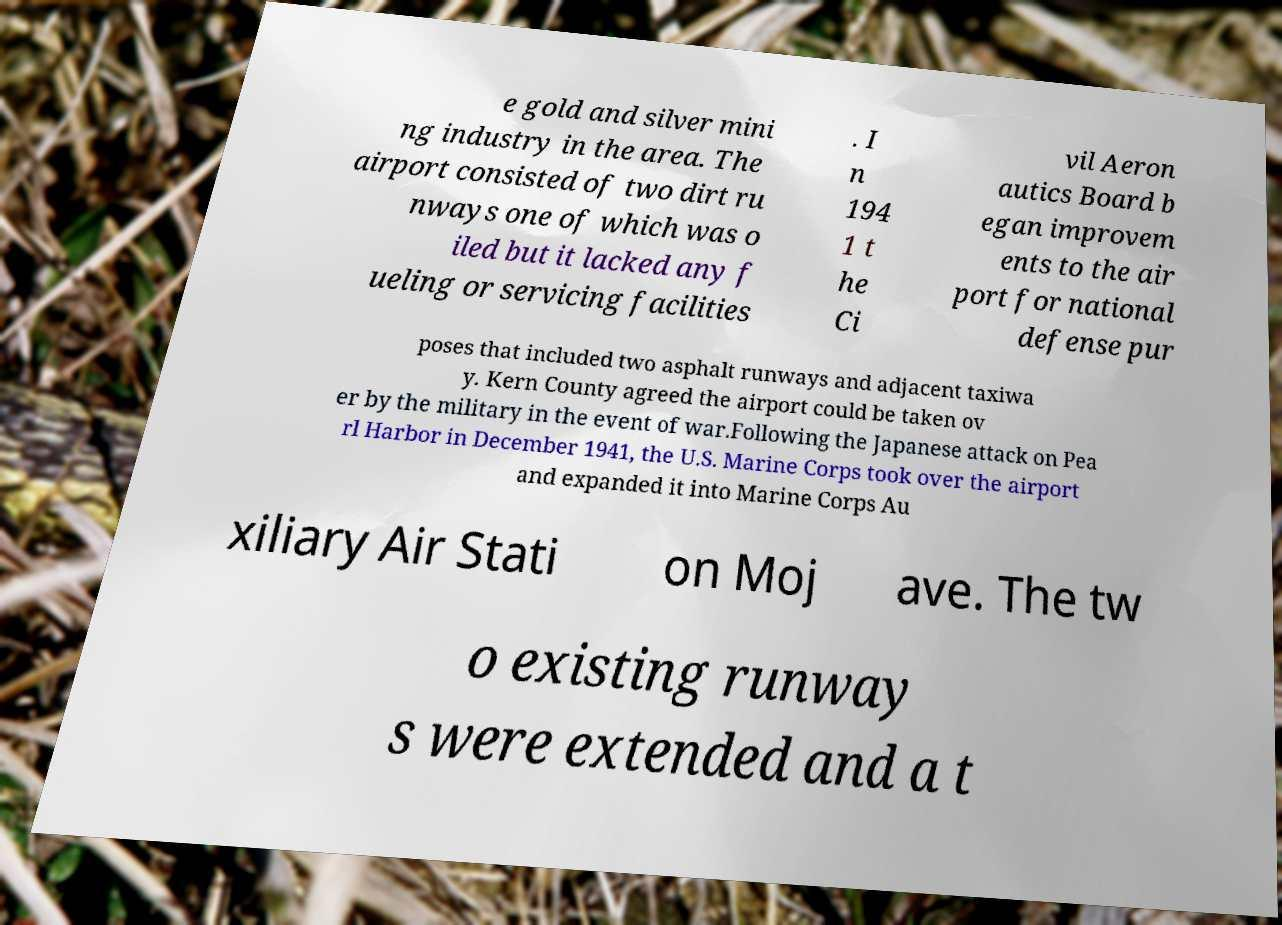What messages or text are displayed in this image? I need them in a readable, typed format. e gold and silver mini ng industry in the area. The airport consisted of two dirt ru nways one of which was o iled but it lacked any f ueling or servicing facilities . I n 194 1 t he Ci vil Aeron autics Board b egan improvem ents to the air port for national defense pur poses that included two asphalt runways and adjacent taxiwa y. Kern County agreed the airport could be taken ov er by the military in the event of war.Following the Japanese attack on Pea rl Harbor in December 1941, the U.S. Marine Corps took over the airport and expanded it into Marine Corps Au xiliary Air Stati on Moj ave. The tw o existing runway s were extended and a t 